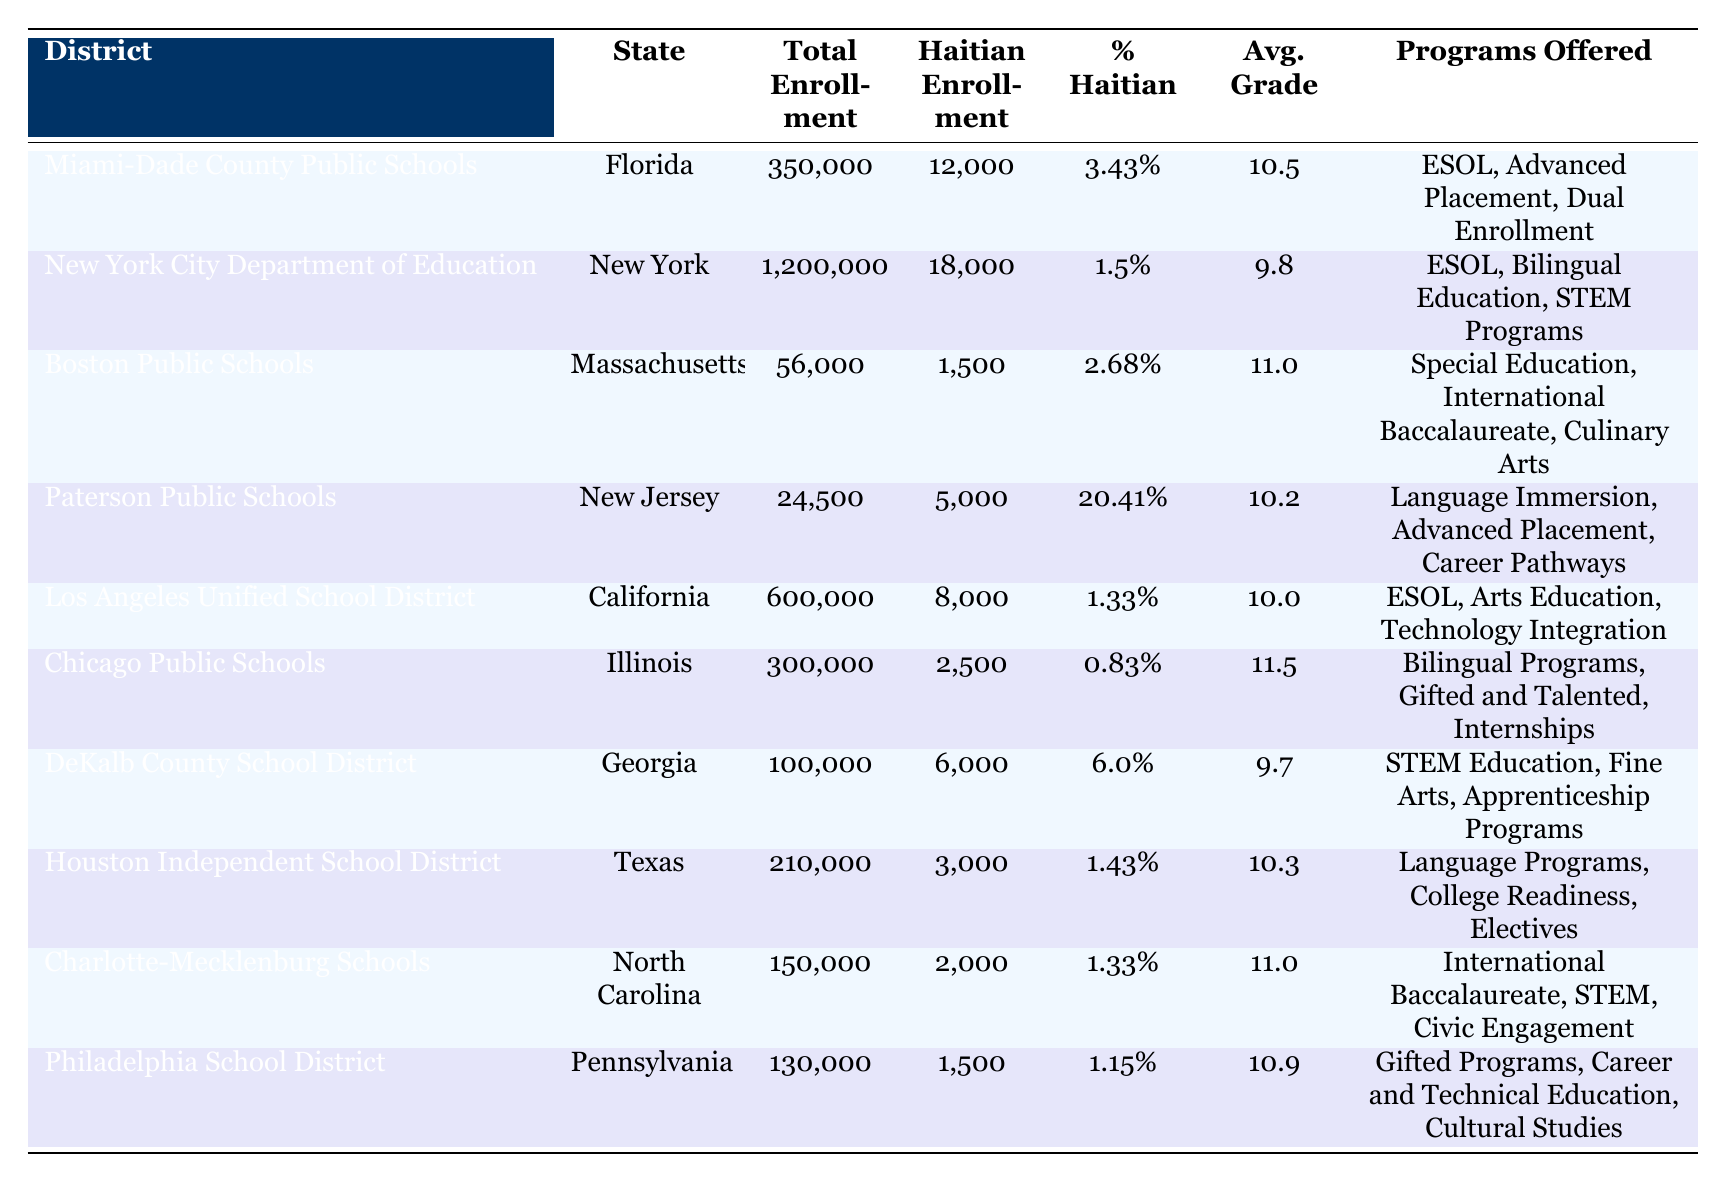What is the total enrollment for Miami-Dade County Public Schools? The table shows that the total enrollment for Miami-Dade County Public Schools is listed under the "Total Enrollment" column, which shows the figure as 350,000.
Answer: 350,000 How many Haitian students are enrolled in New York City Department of Education? The table indicates the Haitian enrollment in the New York City Department of Education under the "Haitian Enrollment" column, showing that there are 18,000 Haitian students enrolled.
Answer: 18,000 Which district has the highest percentage of Haitian students? Looking at the "% Haitian" column, Paterson Public Schools in New Jersey has the highest percentage at 20.41%.
Answer: Paterson Public Schools What is the average grade for Haitian students in Chicago Public Schools? The table indicates that the average grade for Haitian students in Chicago Public Schools is listed in the "Avg. Grade" column as 11.5.
Answer: 11.5 Is the percentage of Haitian students in Los Angeles Unified School District greater than 3%? By checking the "% Haitian" column, Los Angeles Unified School District shows a percentage of 1.33%, which is less than 3%.
Answer: No How many more Haitian students are enrolled in Miami-Dade compared to Paterson Public Schools? The Haitian enrollment in Miami-Dade is 12,000 and for Paterson is 5,000. The difference is calculated as 12,000 - 5,000 = 7,000.
Answer: 7,000 What is the overall total enrollment for the states represented in the table? To find the total enrollment, we sum the total enrollments from all districts: 350,000 + 1,200,000 + 56,000 + 24,500 + 600,000 + 300,000 + 100,000 + 210,000 + 150,000 + 130,000 = 2,920,500.
Answer: 2,920,500 Which state has the lowest Haitian enrollment? By inspecting the "Haitian Enrollment" column, we find that Boston Public Schools in Massachusetts has the lowest enrollment with 1,500 Haitian students.
Answer: Massachusetts (Boston Public Schools) What is the percentage of Haitian students in Georgia's DeKalb County School District compared to the national average of 5%? The percentage in DeKalb County School District is 6.0%, which is greater than the national average of 5%.
Answer: Yes Among the listed programs, which district offers "Advanced Placement"? By reviewing the "Programs Offered" column, both Miami-Dade County Public Schools and Paterson Public Schools are listed to offer Advanced Placement.
Answer: Miami-Dade County and Paterson Public Schools 